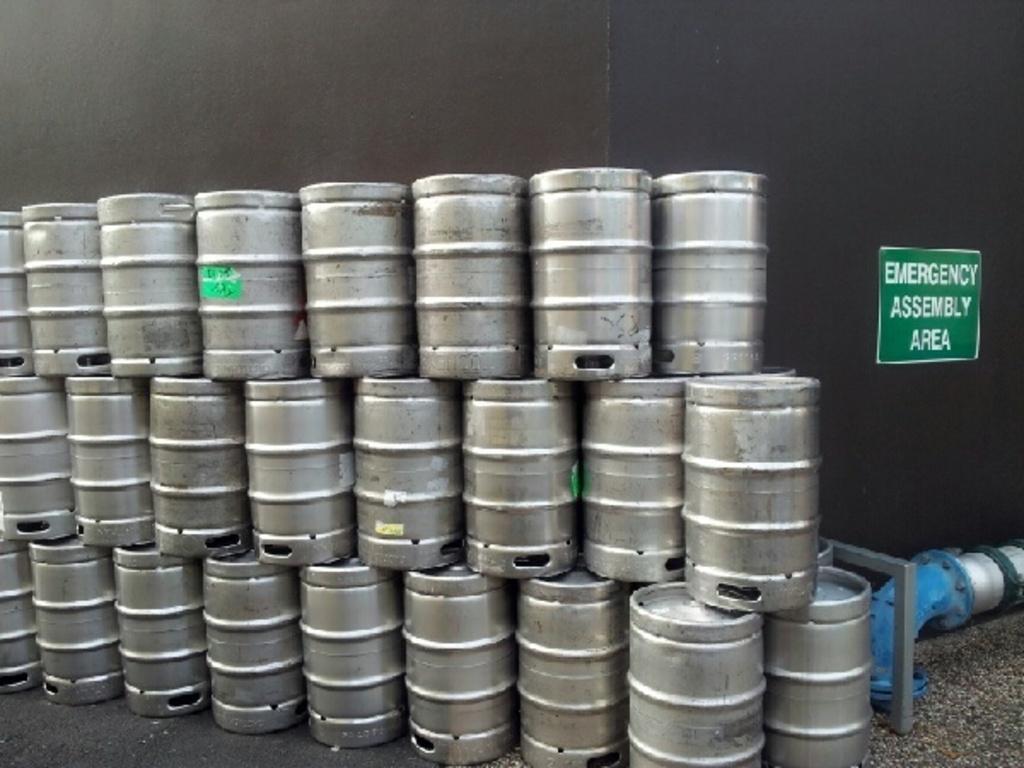Describe this image in one or two sentences. In the center of the image we can see a few metal cans. And we can see some stickers on a few metal cans. In the background there is a wall, rod, pipe and one sign board. On the sign board, we can see some text. 